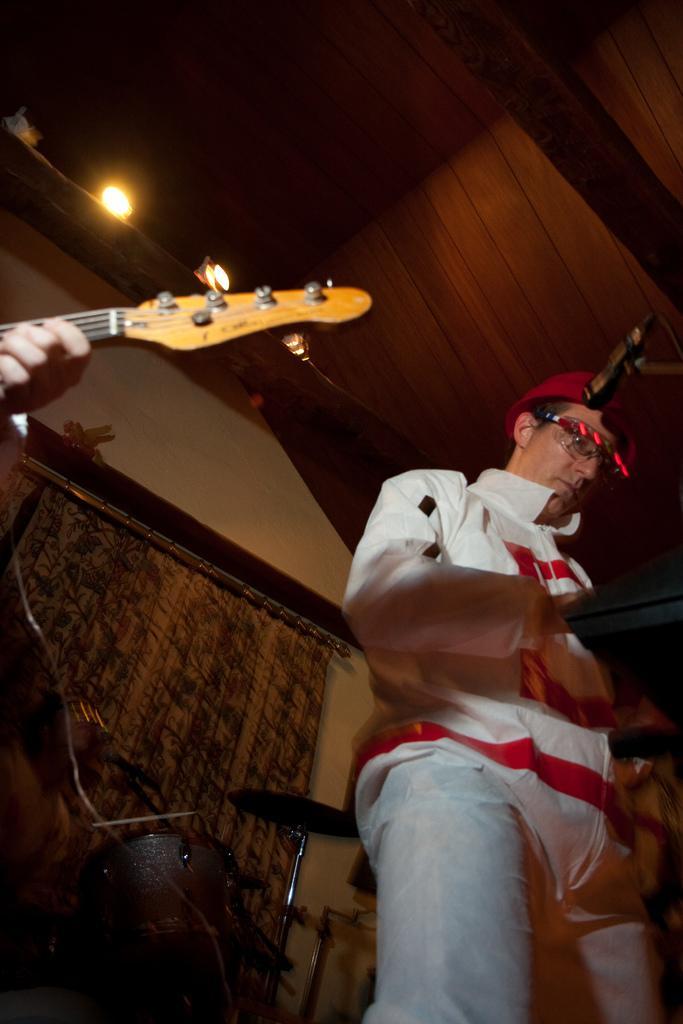Describe this image in one or two sentences. In this image I can see two people playing the musical instruments. In the background I can see few more musical instruments and the curtain. I can see the light at the top. 